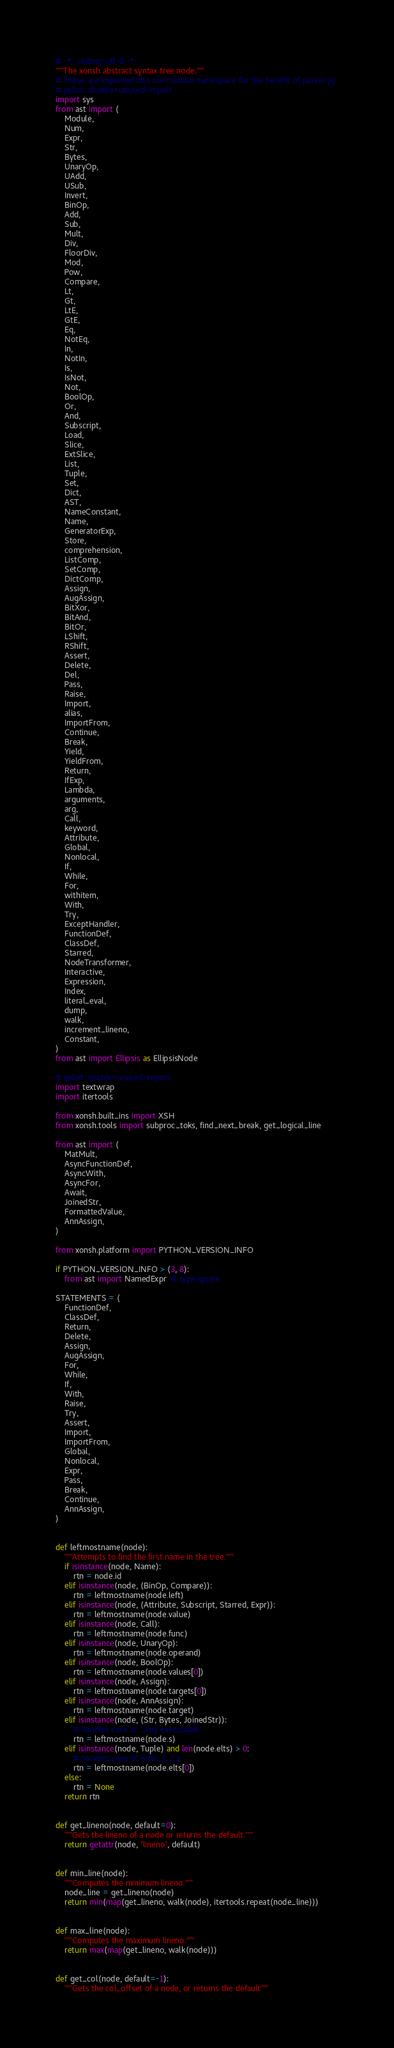Convert code to text. <code><loc_0><loc_0><loc_500><loc_500><_Python_># -*- coding: utf-8 -*-
"""The xonsh abstract syntax tree node."""
# These are imported into our module namespace for the benefit of parser.py.
# pylint: disable=unused-import
import sys
from ast import (
    Module,
    Num,
    Expr,
    Str,
    Bytes,
    UnaryOp,
    UAdd,
    USub,
    Invert,
    BinOp,
    Add,
    Sub,
    Mult,
    Div,
    FloorDiv,
    Mod,
    Pow,
    Compare,
    Lt,
    Gt,
    LtE,
    GtE,
    Eq,
    NotEq,
    In,
    NotIn,
    Is,
    IsNot,
    Not,
    BoolOp,
    Or,
    And,
    Subscript,
    Load,
    Slice,
    ExtSlice,
    List,
    Tuple,
    Set,
    Dict,
    AST,
    NameConstant,
    Name,
    GeneratorExp,
    Store,
    comprehension,
    ListComp,
    SetComp,
    DictComp,
    Assign,
    AugAssign,
    BitXor,
    BitAnd,
    BitOr,
    LShift,
    RShift,
    Assert,
    Delete,
    Del,
    Pass,
    Raise,
    Import,
    alias,
    ImportFrom,
    Continue,
    Break,
    Yield,
    YieldFrom,
    Return,
    IfExp,
    Lambda,
    arguments,
    arg,
    Call,
    keyword,
    Attribute,
    Global,
    Nonlocal,
    If,
    While,
    For,
    withitem,
    With,
    Try,
    ExceptHandler,
    FunctionDef,
    ClassDef,
    Starred,
    NodeTransformer,
    Interactive,
    Expression,
    Index,
    literal_eval,
    dump,
    walk,
    increment_lineno,
    Constant,
)
from ast import Ellipsis as EllipsisNode

# pylint: enable=unused-import
import textwrap
import itertools

from xonsh.built_ins import XSH
from xonsh.tools import subproc_toks, find_next_break, get_logical_line

from ast import (
    MatMult,
    AsyncFunctionDef,
    AsyncWith,
    AsyncFor,
    Await,
    JoinedStr,
    FormattedValue,
    AnnAssign,
)

from xonsh.platform import PYTHON_VERSION_INFO

if PYTHON_VERSION_INFO > (3, 8):
    from ast import NamedExpr  # type:ignore

STATEMENTS = (
    FunctionDef,
    ClassDef,
    Return,
    Delete,
    Assign,
    AugAssign,
    For,
    While,
    If,
    With,
    Raise,
    Try,
    Assert,
    Import,
    ImportFrom,
    Global,
    Nonlocal,
    Expr,
    Pass,
    Break,
    Continue,
    AnnAssign,
)


def leftmostname(node):
    """Attempts to find the first name in the tree."""
    if isinstance(node, Name):
        rtn = node.id
    elif isinstance(node, (BinOp, Compare)):
        rtn = leftmostname(node.left)
    elif isinstance(node, (Attribute, Subscript, Starred, Expr)):
        rtn = leftmostname(node.value)
    elif isinstance(node, Call):
        rtn = leftmostname(node.func)
    elif isinstance(node, UnaryOp):
        rtn = leftmostname(node.operand)
    elif isinstance(node, BoolOp):
        rtn = leftmostname(node.values[0])
    elif isinstance(node, Assign):
        rtn = leftmostname(node.targets[0])
    elif isinstance(node, AnnAssign):
        rtn = leftmostname(node.target)
    elif isinstance(node, (Str, Bytes, JoinedStr)):
        # handles case of "./my executable"
        rtn = leftmostname(node.s)
    elif isinstance(node, Tuple) and len(node.elts) > 0:
        # handles case of echo ,1,2,3
        rtn = leftmostname(node.elts[0])
    else:
        rtn = None
    return rtn


def get_lineno(node, default=0):
    """Gets the lineno of a node or returns the default."""
    return getattr(node, "lineno", default)


def min_line(node):
    """Computes the minimum lineno."""
    node_line = get_lineno(node)
    return min(map(get_lineno, walk(node), itertools.repeat(node_line)))


def max_line(node):
    """Computes the maximum lineno."""
    return max(map(get_lineno, walk(node)))


def get_col(node, default=-1):
    """Gets the col_offset of a node, or returns the default"""</code> 